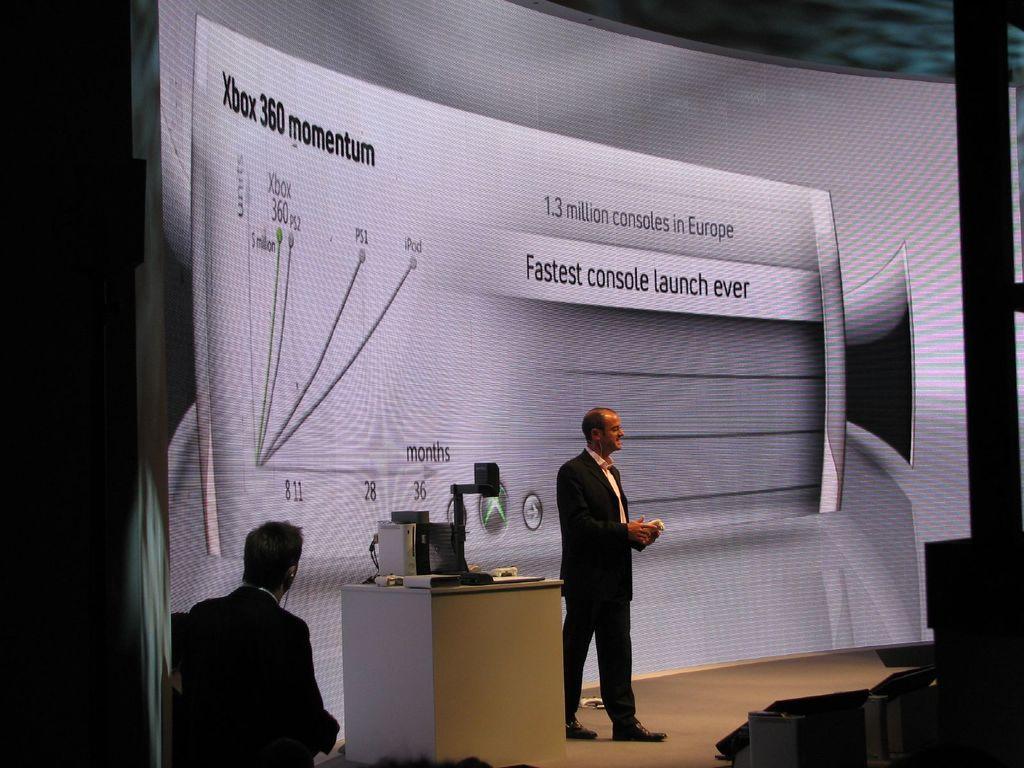In one or two sentences, can you explain what this image depicts? This image consists of two persons. There is a screen in the middle. There is a table at the bottom. On that there is a laptop. 